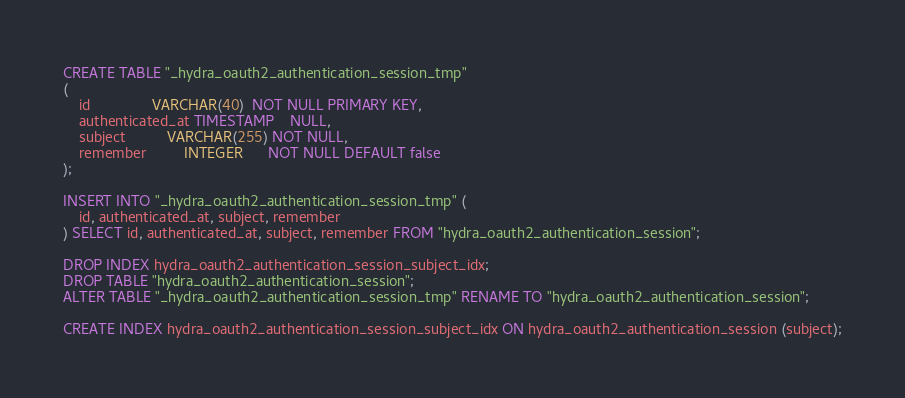Convert code to text. <code><loc_0><loc_0><loc_500><loc_500><_SQL_>CREATE TABLE "_hydra_oauth2_authentication_session_tmp"
(
    id               VARCHAR(40)  NOT NULL PRIMARY KEY,
    authenticated_at TIMESTAMP    NULL,
    subject          VARCHAR(255) NOT NULL,
    remember         INTEGER      NOT NULL DEFAULT false
);

INSERT INTO "_hydra_oauth2_authentication_session_tmp" (
    id, authenticated_at, subject, remember
) SELECT id, authenticated_at, subject, remember FROM "hydra_oauth2_authentication_session";

DROP INDEX hydra_oauth2_authentication_session_subject_idx;
DROP TABLE "hydra_oauth2_authentication_session";
ALTER TABLE "_hydra_oauth2_authentication_session_tmp" RENAME TO "hydra_oauth2_authentication_session";

CREATE INDEX hydra_oauth2_authentication_session_subject_idx ON hydra_oauth2_authentication_session (subject);
</code> 